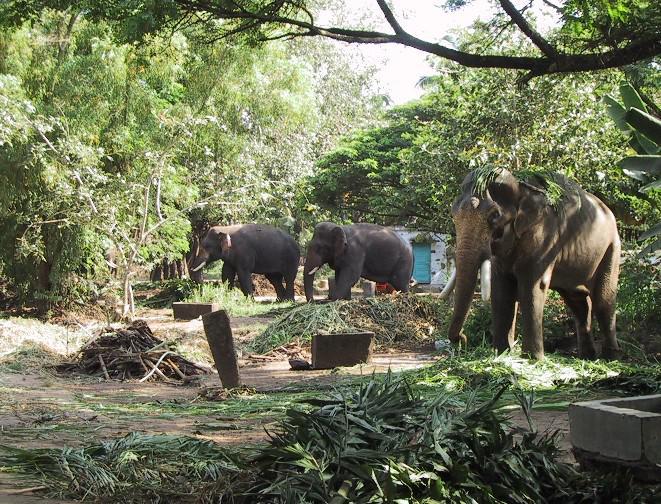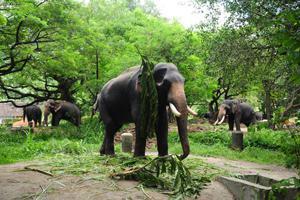The first image is the image on the left, the second image is the image on the right. Assess this claim about the two images: "At least one of the images shows people interacting with an elephant.". Correct or not? Answer yes or no. No. The first image is the image on the left, the second image is the image on the right. For the images displayed, is the sentence "At least one image shows people near an elephant with chained feet." factually correct? Answer yes or no. No. 